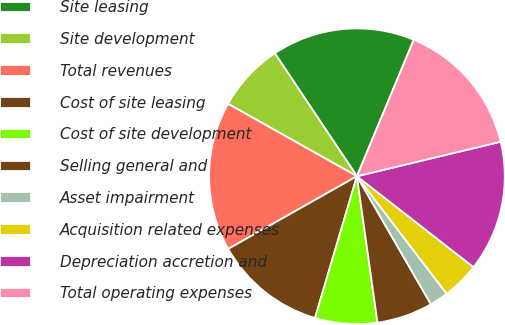<chart> <loc_0><loc_0><loc_500><loc_500><pie_chart><fcel>Site leasing<fcel>Site development<fcel>Total revenues<fcel>Cost of site leasing<fcel>Cost of site development<fcel>Selling general and<fcel>Asset impairment<fcel>Acquisition related expenses<fcel>Depreciation accretion and<fcel>Total operating expenses<nl><fcel>15.65%<fcel>7.48%<fcel>16.33%<fcel>12.24%<fcel>6.8%<fcel>6.12%<fcel>2.04%<fcel>4.08%<fcel>14.29%<fcel>14.97%<nl></chart> 